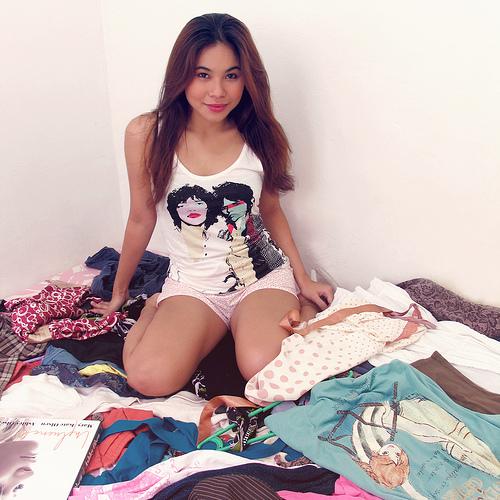Is she surrounded by clothes?
Keep it brief. Yes. Is the girl looking straight at the camera?
Be succinct. Yes. Does she have a lot of choices for things to wear?
Be succinct. Yes. 